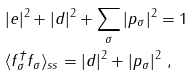<formula> <loc_0><loc_0><loc_500><loc_500>& | e | ^ { 2 } + | d | ^ { 2 } + \sum _ { \sigma } | p _ { \sigma } | ^ { 2 } = 1 \\ & \langle f _ { \sigma } ^ { \dagger } f _ { \sigma } \rangle _ { s s } = | d | ^ { 2 } + | p _ { \sigma } | ^ { 2 } \ ,</formula> 